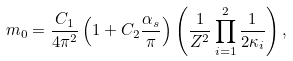Convert formula to latex. <formula><loc_0><loc_0><loc_500><loc_500>m _ { 0 } = \frac { C _ { 1 } } { 4 \pi ^ { 2 } } \left ( 1 + C _ { 2 } \frac { \alpha _ { s } } { \pi } \right ) \left ( \frac { 1 } { Z ^ { 2 } } \prod _ { i = 1 } ^ { 2 } \frac { 1 } { 2 \kappa _ { i } } \right ) ,</formula> 